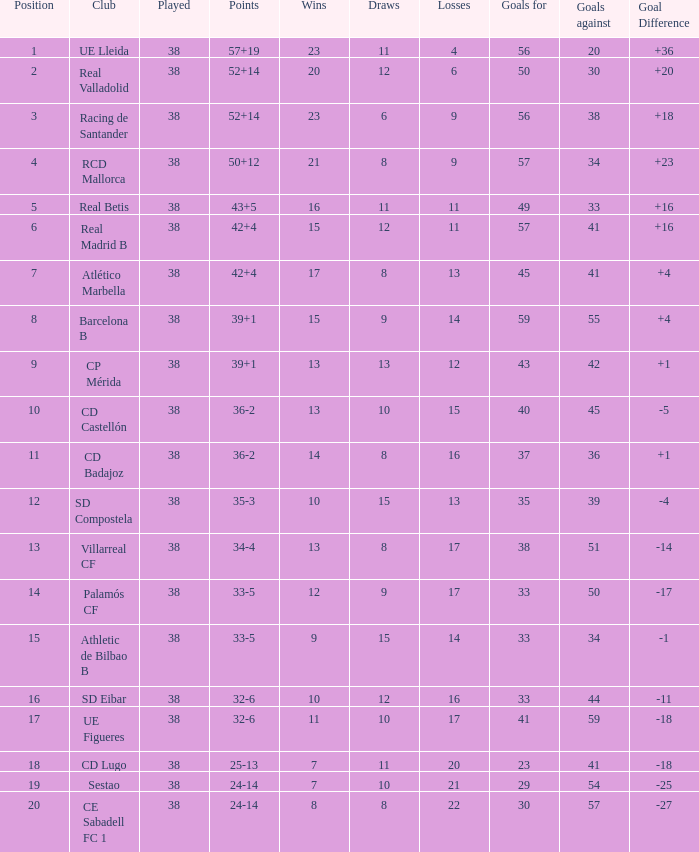What is the highest position with less than 17 losses, more than 57 goals, and a goal difference less than 4? None. 